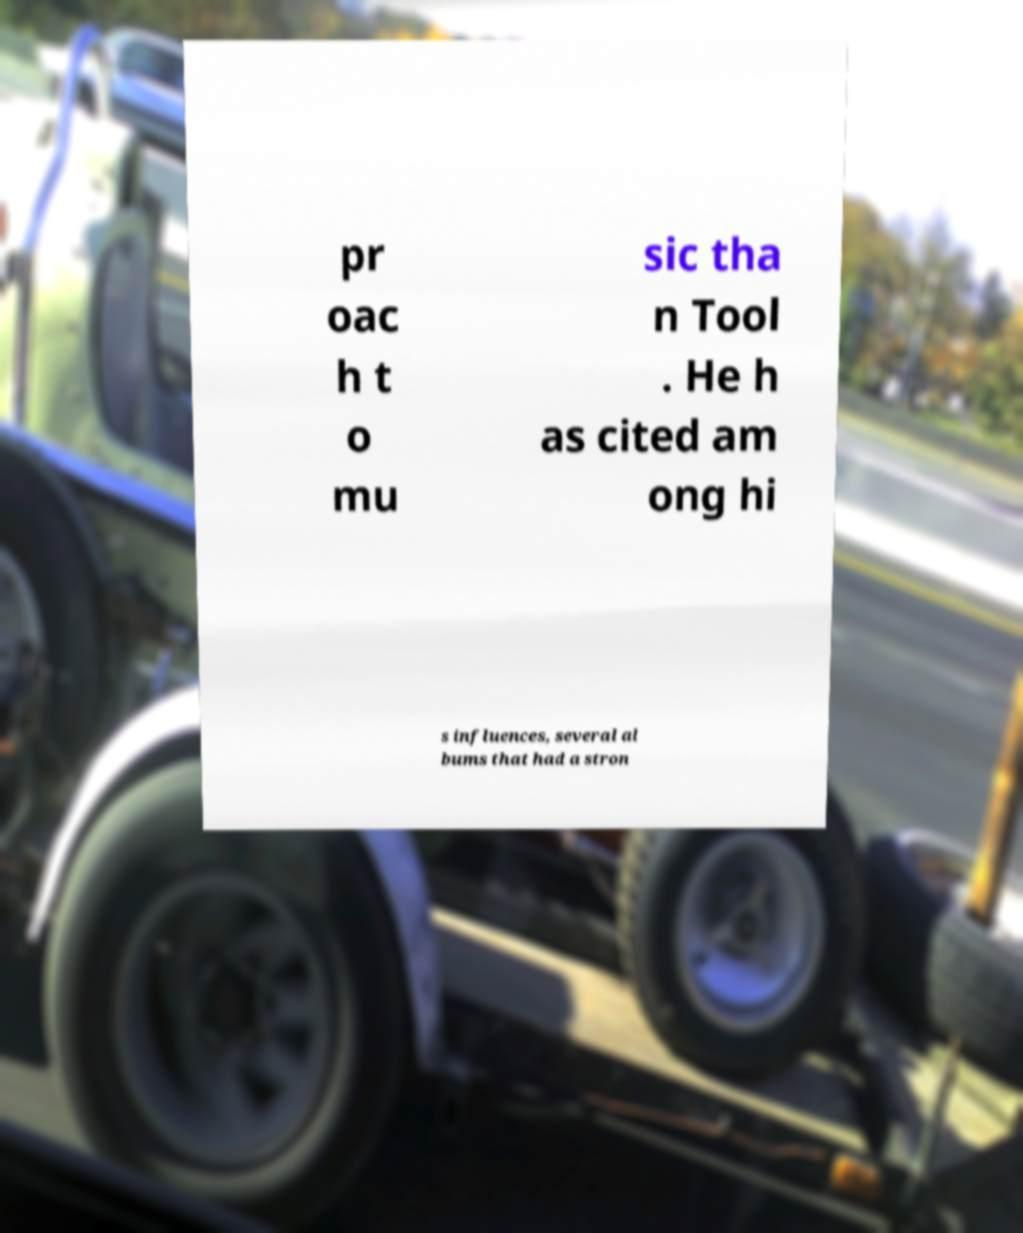Can you read and provide the text displayed in the image?This photo seems to have some interesting text. Can you extract and type it out for me? pr oac h t o mu sic tha n Tool . He h as cited am ong hi s influences, several al bums that had a stron 